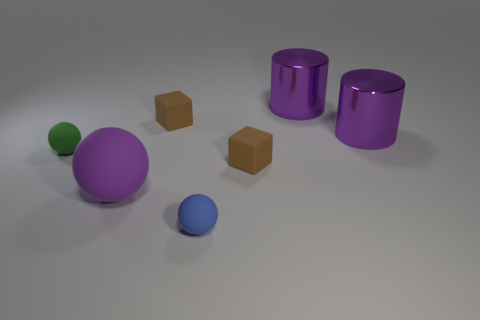Add 2 big red objects. How many objects exist? 9 Subtract all cubes. How many objects are left? 5 Subtract 2 brown blocks. How many objects are left? 5 Subtract all tiny matte objects. Subtract all purple cylinders. How many objects are left? 1 Add 7 small green rubber things. How many small green rubber things are left? 8 Add 7 purple metal cylinders. How many purple metal cylinders exist? 9 